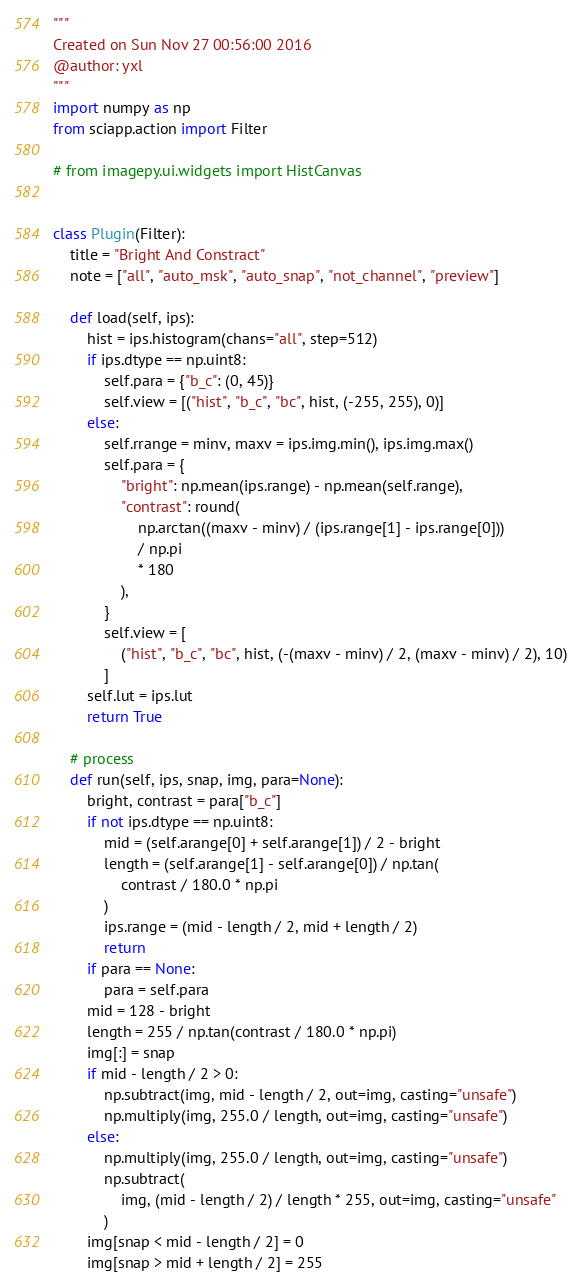<code> <loc_0><loc_0><loc_500><loc_500><_Python_>"""
Created on Sun Nov 27 00:56:00 2016
@author: yxl
"""
import numpy as np
from sciapp.action import Filter

# from imagepy.ui.widgets import HistCanvas


class Plugin(Filter):
    title = "Bright And Constract"
    note = ["all", "auto_msk", "auto_snap", "not_channel", "preview"]

    def load(self, ips):
        hist = ips.histogram(chans="all", step=512)
        if ips.dtype == np.uint8:
            self.para = {"b_c": (0, 45)}
            self.view = [("hist", "b_c", "bc", hist, (-255, 255), 0)]
        else:
            self.rrange = minv, maxv = ips.img.min(), ips.img.max()
            self.para = {
                "bright": np.mean(ips.range) - np.mean(self.range),
                "contrast": round(
                    np.arctan((maxv - minv) / (ips.range[1] - ips.range[0]))
                    / np.pi
                    * 180
                ),
            }
            self.view = [
                ("hist", "b_c", "bc", hist, (-(maxv - minv) / 2, (maxv - minv) / 2), 10)
            ]
        self.lut = ips.lut
        return True

    # process
    def run(self, ips, snap, img, para=None):
        bright, contrast = para["b_c"]
        if not ips.dtype == np.uint8:
            mid = (self.arange[0] + self.arange[1]) / 2 - bright
            length = (self.arange[1] - self.arange[0]) / np.tan(
                contrast / 180.0 * np.pi
            )
            ips.range = (mid - length / 2, mid + length / 2)
            return
        if para == None:
            para = self.para
        mid = 128 - bright
        length = 255 / np.tan(contrast / 180.0 * np.pi)
        img[:] = snap
        if mid - length / 2 > 0:
            np.subtract(img, mid - length / 2, out=img, casting="unsafe")
            np.multiply(img, 255.0 / length, out=img, casting="unsafe")
        else:
            np.multiply(img, 255.0 / length, out=img, casting="unsafe")
            np.subtract(
                img, (mid - length / 2) / length * 255, out=img, casting="unsafe"
            )
        img[snap < mid - length / 2] = 0
        img[snap > mid + length / 2] = 255
</code> 